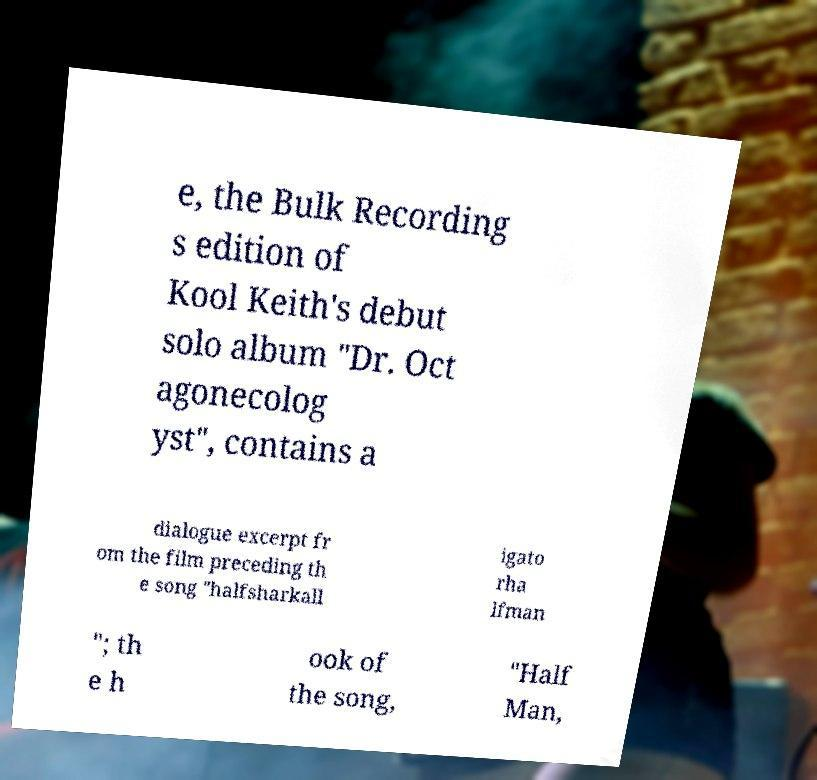Please identify and transcribe the text found in this image. e, the Bulk Recording s edition of Kool Keith's debut solo album "Dr. Oct agonecolog yst", contains a dialogue excerpt fr om the film preceding th e song "halfsharkall igato rha lfman "; th e h ook of the song, "Half Man, 